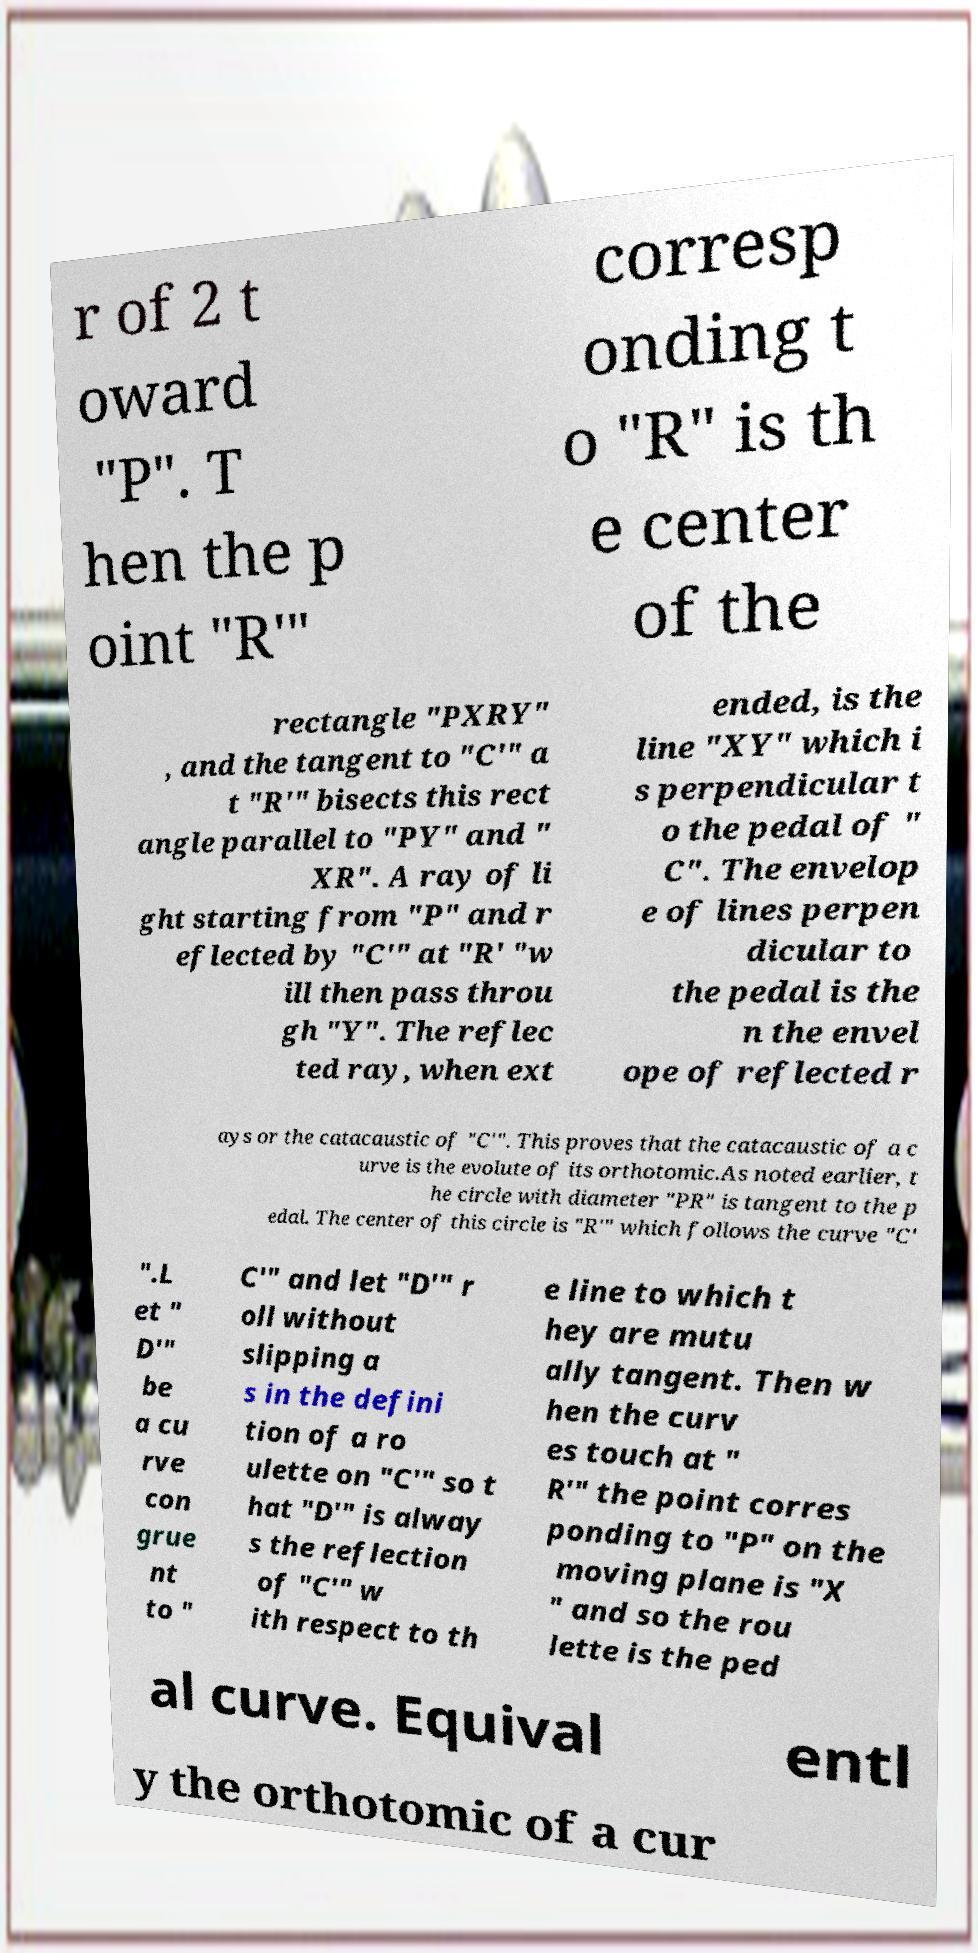Please identify and transcribe the text found in this image. r of 2 t oward "P". T hen the p oint "R′" corresp onding t o "R" is th e center of the rectangle "PXRY" , and the tangent to "C′" a t "R′" bisects this rect angle parallel to "PY" and " XR". A ray of li ght starting from "P" and r eflected by "C′" at "R' "w ill then pass throu gh "Y". The reflec ted ray, when ext ended, is the line "XY" which i s perpendicular t o the pedal of " C". The envelop e of lines perpen dicular to the pedal is the n the envel ope of reflected r ays or the catacaustic of "C′". This proves that the catacaustic of a c urve is the evolute of its orthotomic.As noted earlier, t he circle with diameter "PR" is tangent to the p edal. The center of this circle is "R′" which follows the curve "C′ ".L et " D′" be a cu rve con grue nt to " C′" and let "D′" r oll without slipping a s in the defini tion of a ro ulette on "C′" so t hat "D′" is alway s the reflection of "C′" w ith respect to th e line to which t hey are mutu ally tangent. Then w hen the curv es touch at " R′" the point corres ponding to "P" on the moving plane is "X " and so the rou lette is the ped al curve. Equival entl y the orthotomic of a cur 